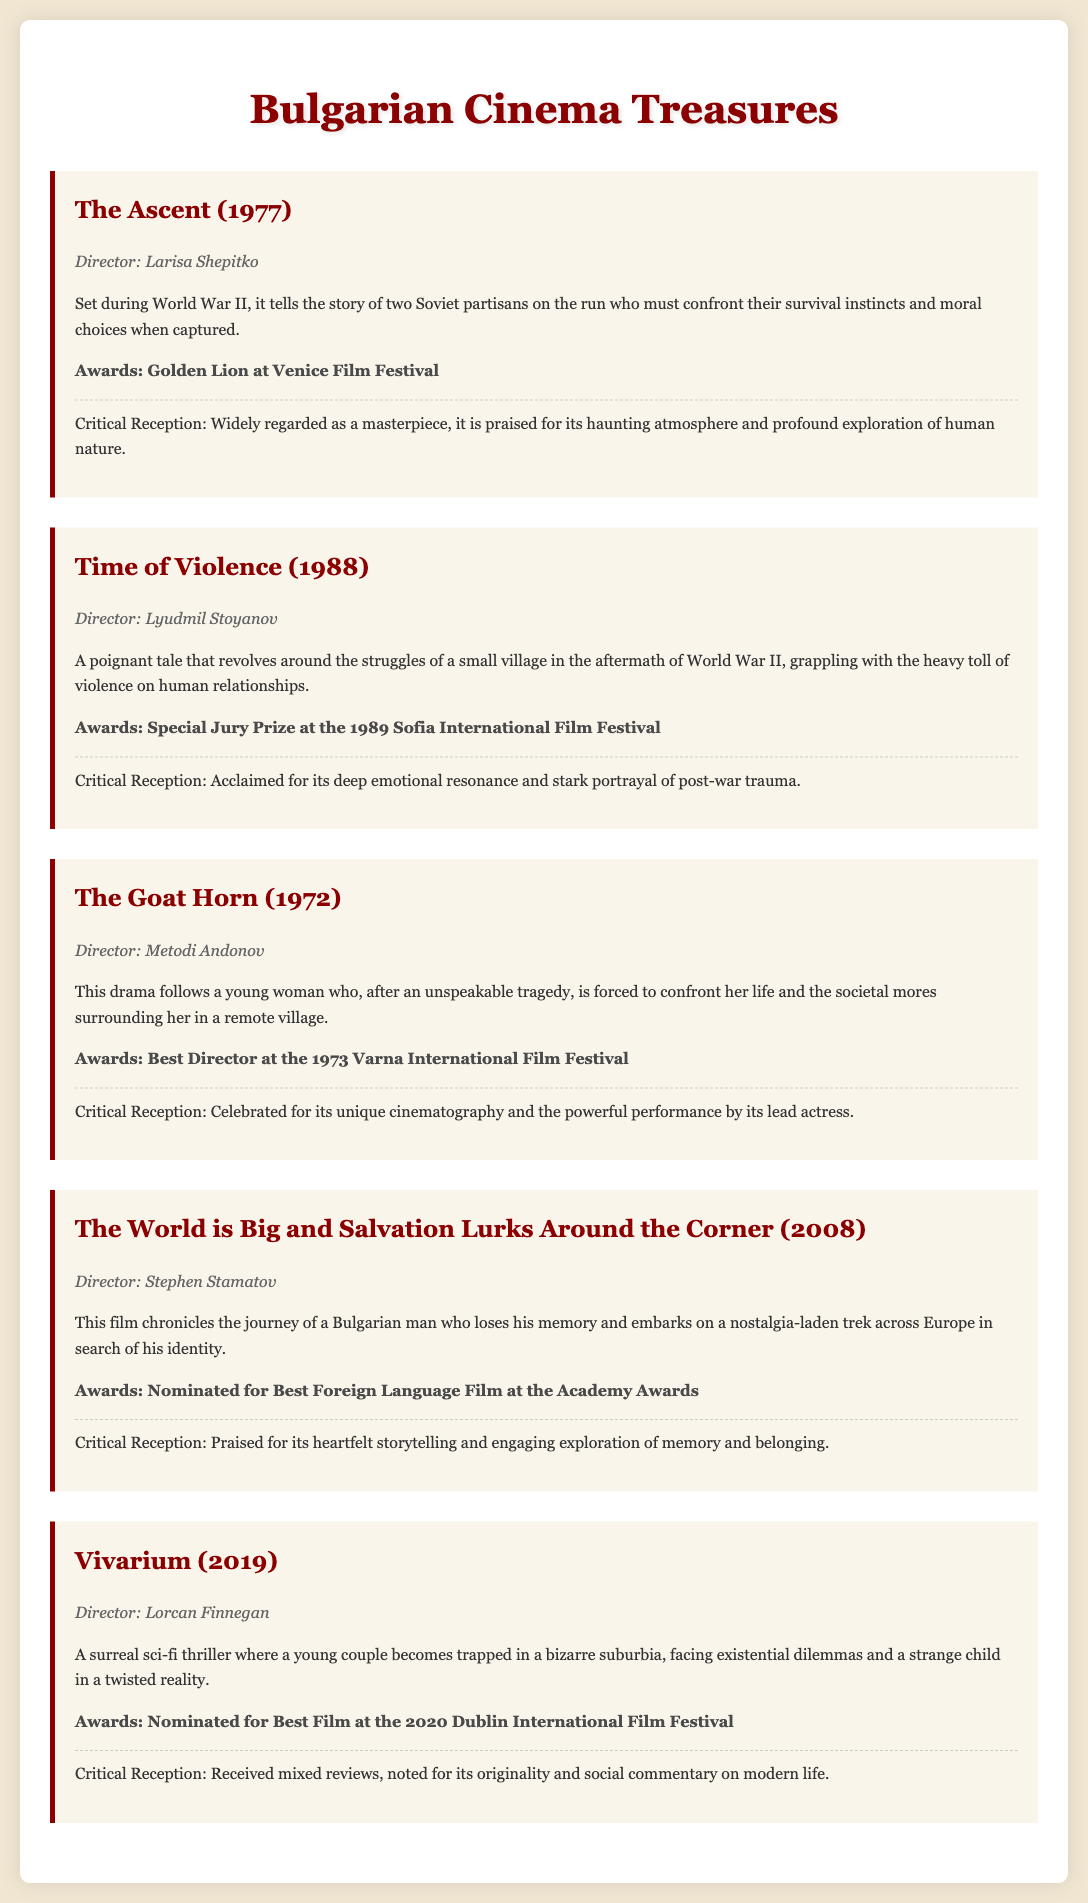What is the title of the film released in 1977? The title is explicitly stated under the film details for the year 1977.
Answer: The Ascent Who directed Time of Violence? The director's name is mentioned alongside the film title in the document.
Answer: Lyudmil Stoyanov Which film won the Golden Lion at the Venice Film Festival? This award is listed under the relevant film's details in the document.
Answer: The Ascent What year was The Goat Horn released? The release year can be found in the film's heading in the document.
Answer: 1972 How many awards did The World is Big and Salvation Lurks Around the Corner receive? The document specifies one major nomination for this film.
Answer: One Which film is described as a surreal sci-fi thriller? The documentary description provides this information distinctly.
Answer: Vivarium What themes does Time of Violence explore? The synopsis clearly outlines the themes reflected in the film.
Answer: Post-war trauma Which film features a journey across Europe? The synopsis mentions a journey in the film details.
Answer: The World is Big and Salvation Lurks Around the Corner What award did The Goat Horn win at the Varna International Film Festival? The specific award is mentioned in the film's awards section.
Answer: Best Director 